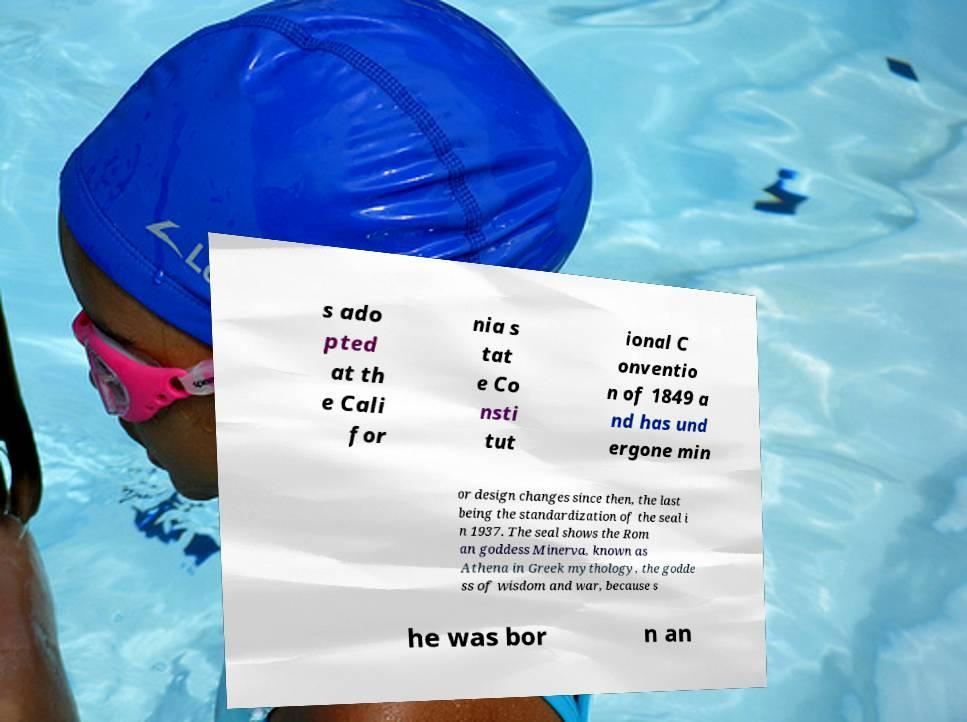Please identify and transcribe the text found in this image. s ado pted at th e Cali for nia s tat e Co nsti tut ional C onventio n of 1849 a nd has und ergone min or design changes since then, the last being the standardization of the seal i n 1937. The seal shows the Rom an goddess Minerva, known as Athena in Greek mythology, the godde ss of wisdom and war, because s he was bor n an 